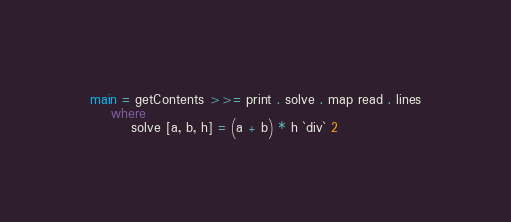<code> <loc_0><loc_0><loc_500><loc_500><_Haskell_>main = getContents >>= print . solve . map read . lines
    where
        solve [a, b, h] = (a + b) * h `div` 2
</code> 